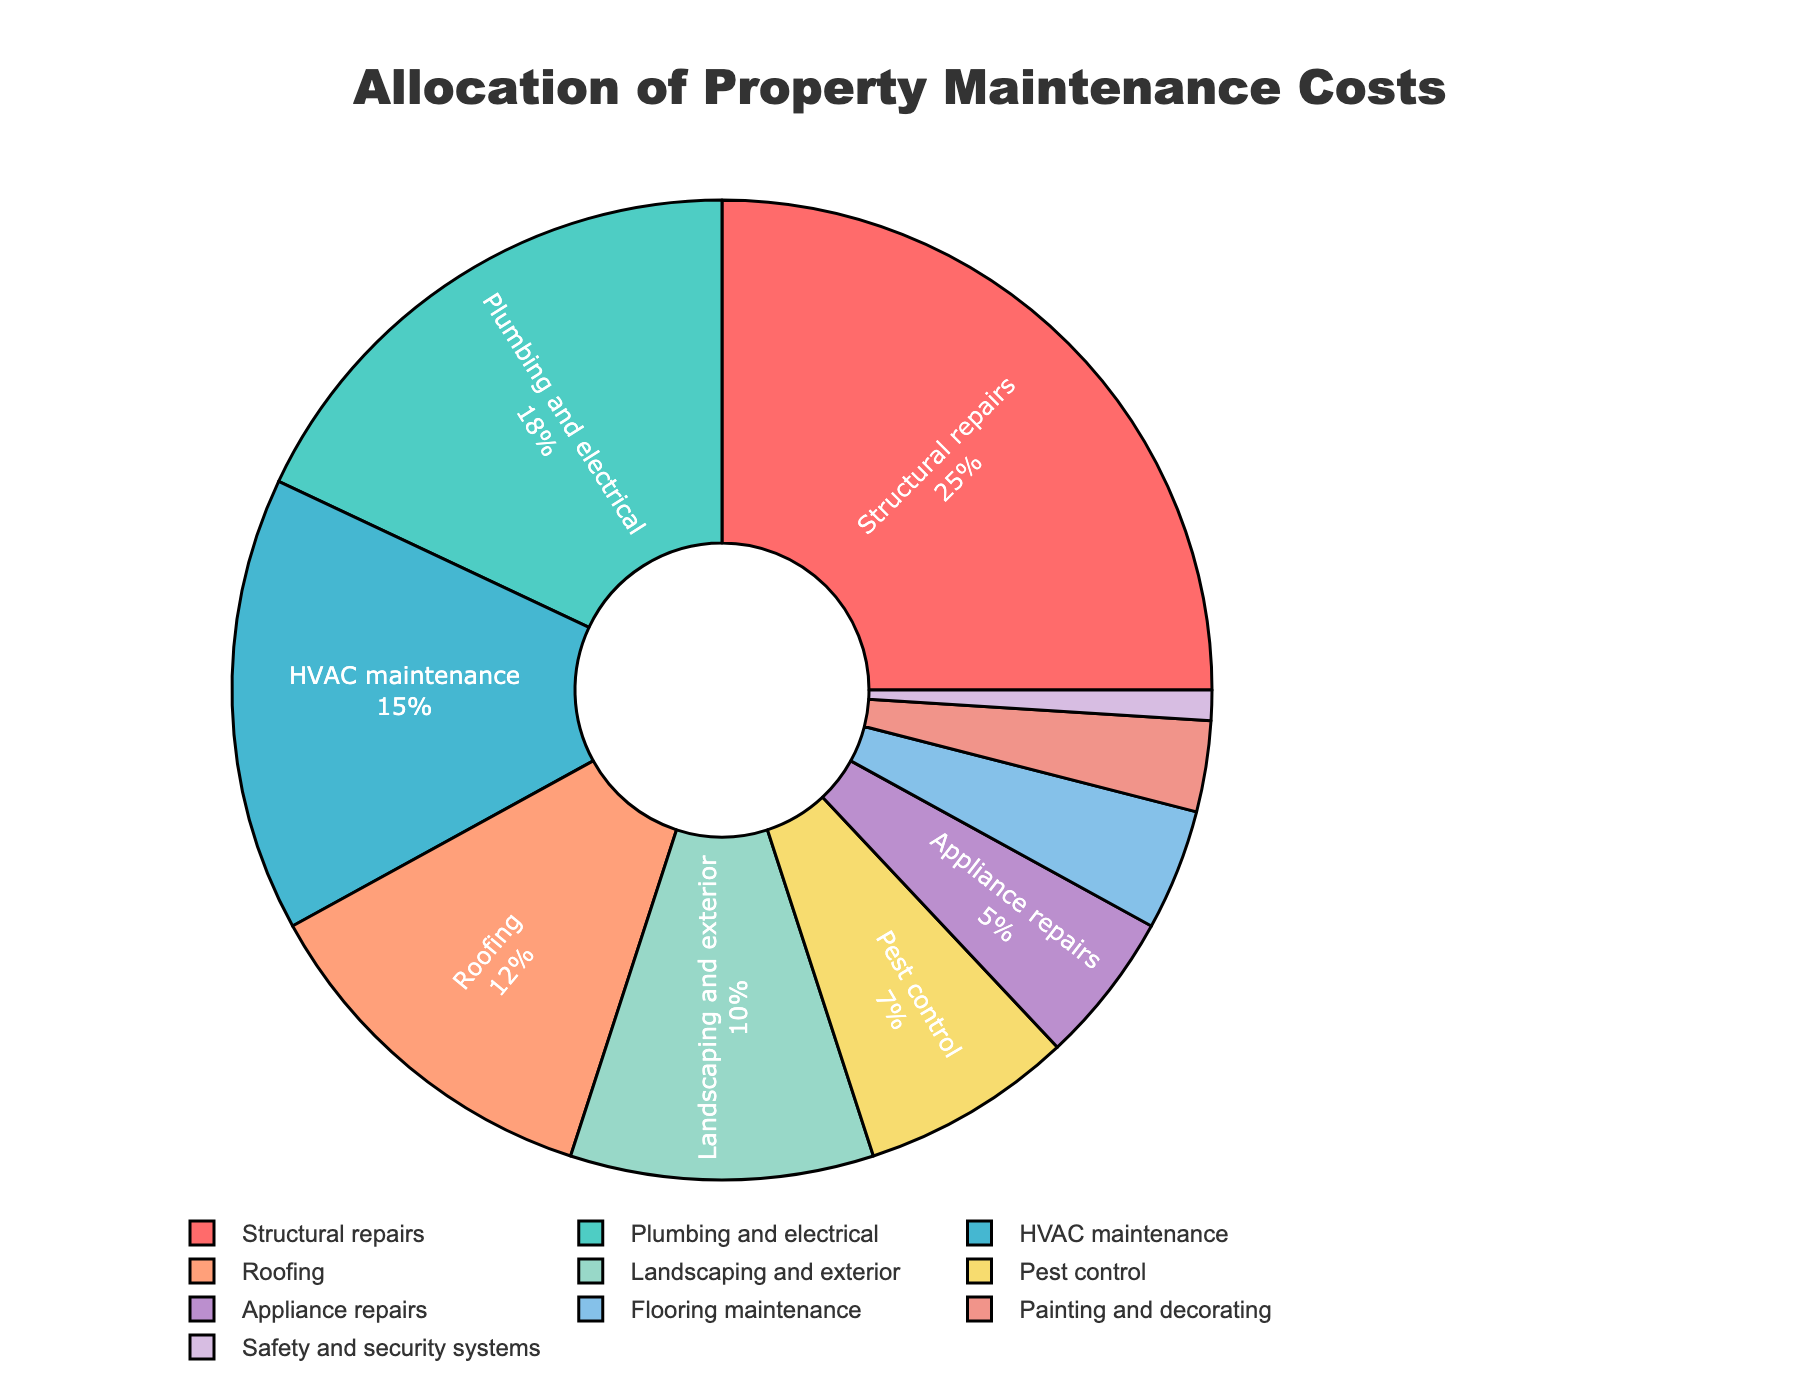What category has the highest allocation of maintenance costs? The largest slice in the pie chart represents Structural repairs, which occupies the biggest area compared to the other categories.
Answer: Structural repairs (25%) What is the combined percentage of HVAC maintenance, Pest control, and Flooring maintenance costs? Add the percentages for HVAC maintenance, Pest control, and Flooring maintenance: 15% + 7% + 4% = 26%
Answer: 26% Which category has a higher maintenance cost allocation: Plumbing and electrical or Roofing? By comparing the sizes of the slices, we see that Plumbing and electrical (18%) is larger than Roofing (12%).
Answer: Plumbing and electrical (18%) How much more is spent on Landscaping and exterior compared to Painting and decorating? Subtract the percentage of Painting and decorating from Landscaping and exterior: 10% - 3% = 7%
Answer: 7% Which category has less than 5% allocation in the maintenance costs? Identify the slices with less than 5% allocation, which are Appliance repairs (5%), Flooring maintenance (4%), Painting and decorating (3%), and Safety and security systems (1%).
Answer: Safety and security systems (1%) What is the total percentage of categories related to interior maintenance (Plumbing and electrical, Appliance repairs, Flooring maintenance, Painting and decorating)? Sum the percentages for Plumbing and electrical, Appliance repairs, Flooring maintenance, and Painting and decorating: 18% + 5% + 4% + 3% = 30%
Answer: 30% How do the costs for Structural repairs compare to the costs for HVAC maintenance? Structural repairs occupy 25% while HVAC maintenance occupies 15%. Therefore, Structural repairs have a higher allocation by 10%.
Answer: Structural repairs are 10% higher What fraction of the total maintenance costs is spent on Roofing and Landscaping and exterior combined? Add the percentages of Roofing and Landscaping and exterior: 12% + 10% = 22%. The fraction is 22/100 or 22%.
Answer: 22% Which category has the smallest allocation, and what is its percentage? The smallest slice represents Safety and security systems, which has the smallest percentage of 1%.
Answer: Safety and security systems (1%) If the percentage allocated to Pest control doubled, what would be the new percentage, and how would it compare to the percentage for HVAC maintenance? Doubling the percentage for Pest control: 7% * 2 = 14%. Compare this to HVAC maintenance, which is 15%. Pest control's new allocation would be 14%, just 1% less than HVAC maintenance.
Answer: 14%, 1% less than HVAC maintenance (15%) 